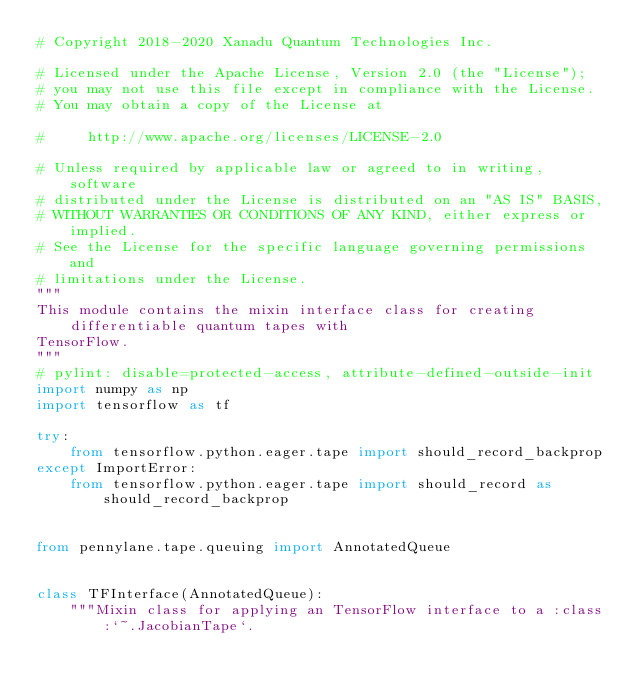<code> <loc_0><loc_0><loc_500><loc_500><_Python_># Copyright 2018-2020 Xanadu Quantum Technologies Inc.

# Licensed under the Apache License, Version 2.0 (the "License");
# you may not use this file except in compliance with the License.
# You may obtain a copy of the License at

#     http://www.apache.org/licenses/LICENSE-2.0

# Unless required by applicable law or agreed to in writing, software
# distributed under the License is distributed on an "AS IS" BASIS,
# WITHOUT WARRANTIES OR CONDITIONS OF ANY KIND, either express or implied.
# See the License for the specific language governing permissions and
# limitations under the License.
"""
This module contains the mixin interface class for creating differentiable quantum tapes with
TensorFlow.
"""
# pylint: disable=protected-access, attribute-defined-outside-init
import numpy as np
import tensorflow as tf

try:
    from tensorflow.python.eager.tape import should_record_backprop
except ImportError:
    from tensorflow.python.eager.tape import should_record as should_record_backprop


from pennylane.tape.queuing import AnnotatedQueue


class TFInterface(AnnotatedQueue):
    """Mixin class for applying an TensorFlow interface to a :class:`~.JacobianTape`.
</code> 